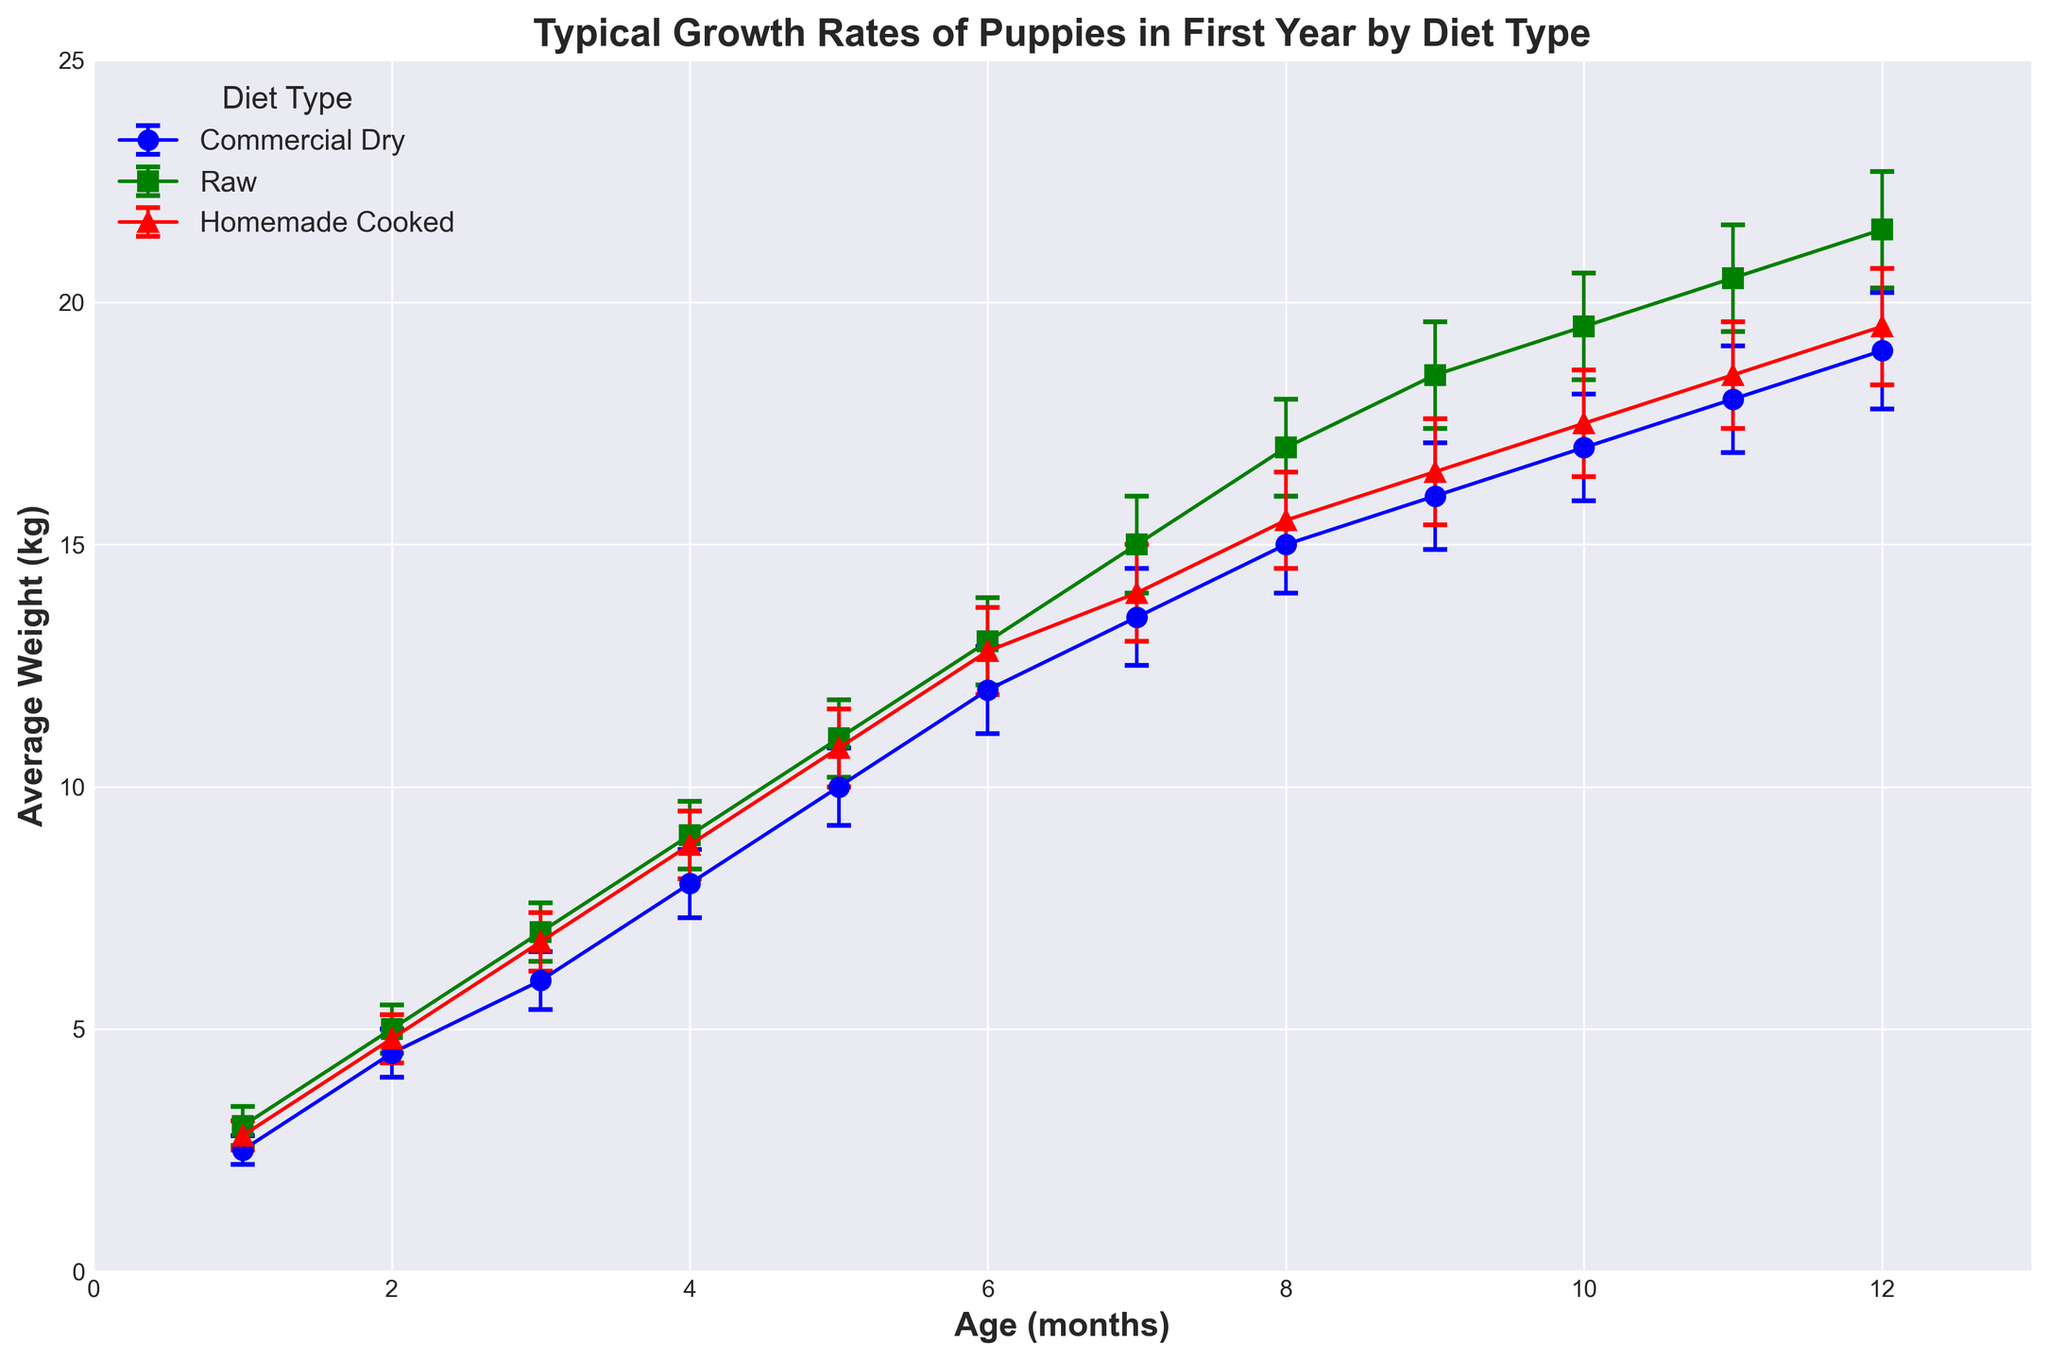Which diet type shows the highest average weight at 12 months? The figure shows the 12-month average weight values for each diet type. By inspecting the height of the points at 12 months, the Raw diet shows the highest average weight.
Answer: Raw What is the weight difference between puppies on Commercial Dry and Homemade Cooked diets at 6 months? The weights at 6 months for Commercial Dry and Homemade Cooked diets are 12.0 kg and 12.8 kg, respectively. The difference is calculated as 12.8 - 12.0 = 0.8 kg.
Answer: 0.8 kg At what age do puppies on a Raw diet reach an average weight of 17 kg? Looking at the points labeled for the Raw diet, the average weight of 17 kg is reached at 8 months.
Answer: 8 months Compare the average weights of puppies on Commercial Dry and Raw diets at 4 months. Which one is higher and by how much? The average weight at 4 months for Commercial Dry is 8.0 kg and for Raw it is 9.0 kg. Raw is higher by 9.0 - 8.0 = 1 kg.
Answer: Raw by 1 kg What is the average weight gain per month for puppies on a Homemade Cooked diet between 1 and 12 months? The 1-month weight is 2.8 kg and the 12-month weight is 19.5 kg for Homemade Cooked. The weight gain over 11 months is 19.5 - 2.8 = 16.7 kg. The average monthly weight gain is 16.7 / 11 ≈ 1.52 kg.
Answer: 1.52 kg At 10 months, which diet shows the least variability in weight? By examining the error bars at 10 months, Commercial Dry and Homemade Cooked both show a standard deviation of 1.1 kg. Raw also shows a standard deviation of 1.1 kg, so there is no difference in variability.
Answer: All equal Which age group shows the largest standard deviation for the Commercial Dry diet? Looking at the heights of the error bars for the Commercial Dry diet, the largest standard deviation of 1.2 kg is at 12 months.
Answer: 12 months Do all diet types show a linear growth pattern in the first year? By visually inspecting the weight versus age for all three diet types, all seem to have a linear pattern of growth over the first 12 months, as the lines appear to be straight.
Answer: Yes 